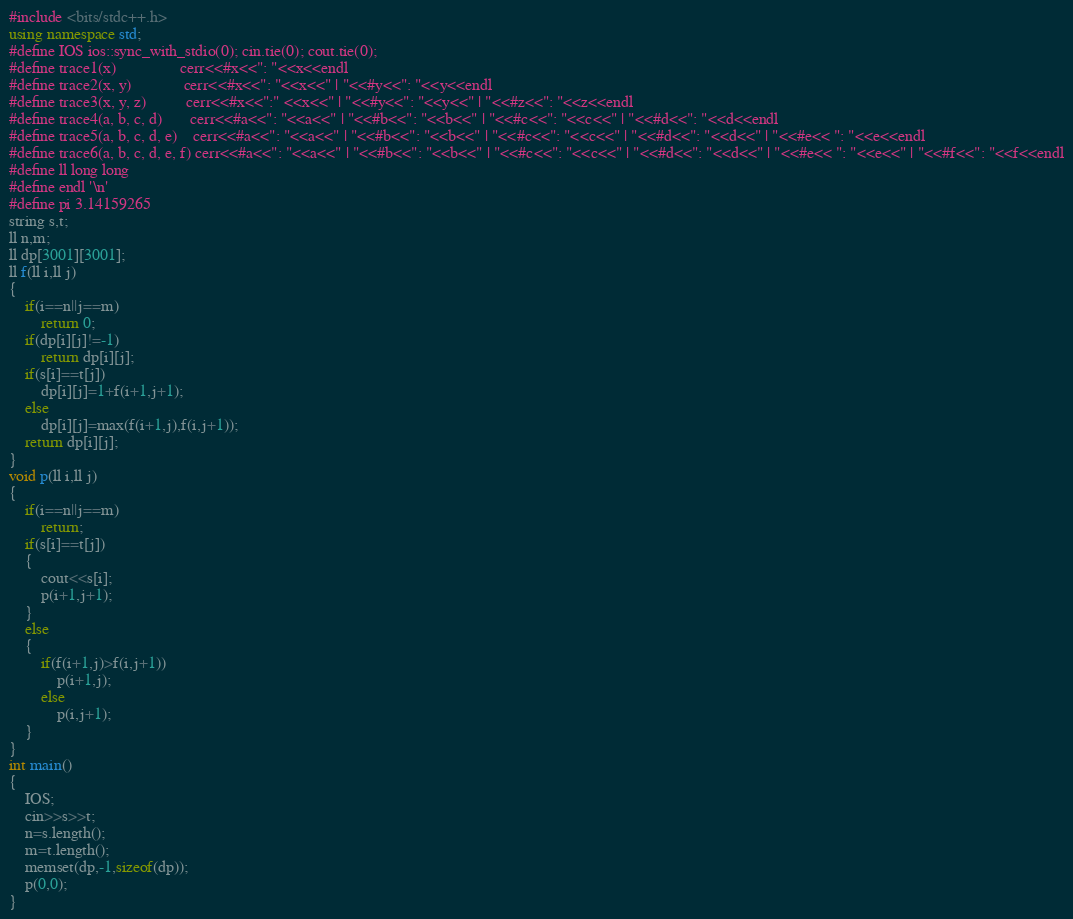Convert code to text. <code><loc_0><loc_0><loc_500><loc_500><_C++_>#include <bits/stdc++.h>
using namespace std;
#define IOS ios::sync_with_stdio(0); cin.tie(0); cout.tie(0);
#define trace1(x)                cerr<<#x<<": "<<x<<endl
#define trace2(x, y)             cerr<<#x<<": "<<x<<" | "<<#y<<": "<<y<<endl
#define trace3(x, y, z)          cerr<<#x<<":" <<x<<" | "<<#y<<": "<<y<<" | "<<#z<<": "<<z<<endl
#define trace4(a, b, c, d)       cerr<<#a<<": "<<a<<" | "<<#b<<": "<<b<<" | "<<#c<<": "<<c<<" | "<<#d<<": "<<d<<endl
#define trace5(a, b, c, d, e)    cerr<<#a<<": "<<a<<" | "<<#b<<": "<<b<<" | "<<#c<<": "<<c<<" | "<<#d<<": "<<d<<" | "<<#e<< ": "<<e<<endl
#define trace6(a, b, c, d, e, f) cerr<<#a<<": "<<a<<" | "<<#b<<": "<<b<<" | "<<#c<<": "<<c<<" | "<<#d<<": "<<d<<" | "<<#e<< ": "<<e<<" | "<<#f<<": "<<f<<endl
#define ll long long
#define endl '\n'
#define pi 3.14159265
string s,t;
ll n,m;
ll dp[3001][3001];
ll f(ll i,ll j)
{
    if(i==n||j==m)
        return 0;
    if(dp[i][j]!=-1)
        return dp[i][j];
    if(s[i]==t[j])
        dp[i][j]=1+f(i+1,j+1);
    else
        dp[i][j]=max(f(i+1,j),f(i,j+1));
    return dp[i][j];
}
void p(ll i,ll j)
{
    if(i==n||j==m)
        return;
    if(s[i]==t[j])
    {
        cout<<s[i];
        p(i+1,j+1);
    }
    else
    {
        if(f(i+1,j)>f(i,j+1))
            p(i+1,j);
        else
            p(i,j+1);
    }
}
int main()
{
    IOS;
    cin>>s>>t;
    n=s.length();
    m=t.length();
    memset(dp,-1,sizeof(dp));
    p(0,0);
}</code> 